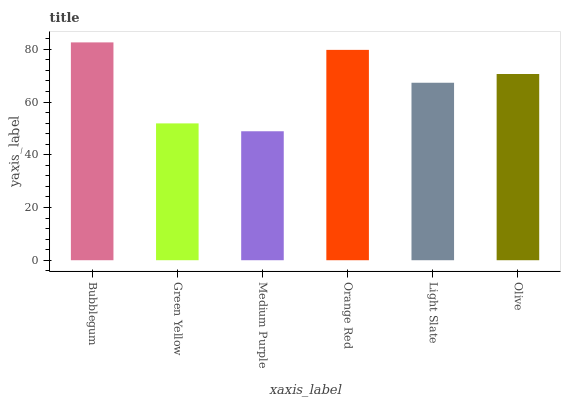Is Medium Purple the minimum?
Answer yes or no. Yes. Is Bubblegum the maximum?
Answer yes or no. Yes. Is Green Yellow the minimum?
Answer yes or no. No. Is Green Yellow the maximum?
Answer yes or no. No. Is Bubblegum greater than Green Yellow?
Answer yes or no. Yes. Is Green Yellow less than Bubblegum?
Answer yes or no. Yes. Is Green Yellow greater than Bubblegum?
Answer yes or no. No. Is Bubblegum less than Green Yellow?
Answer yes or no. No. Is Olive the high median?
Answer yes or no. Yes. Is Light Slate the low median?
Answer yes or no. Yes. Is Light Slate the high median?
Answer yes or no. No. Is Olive the low median?
Answer yes or no. No. 